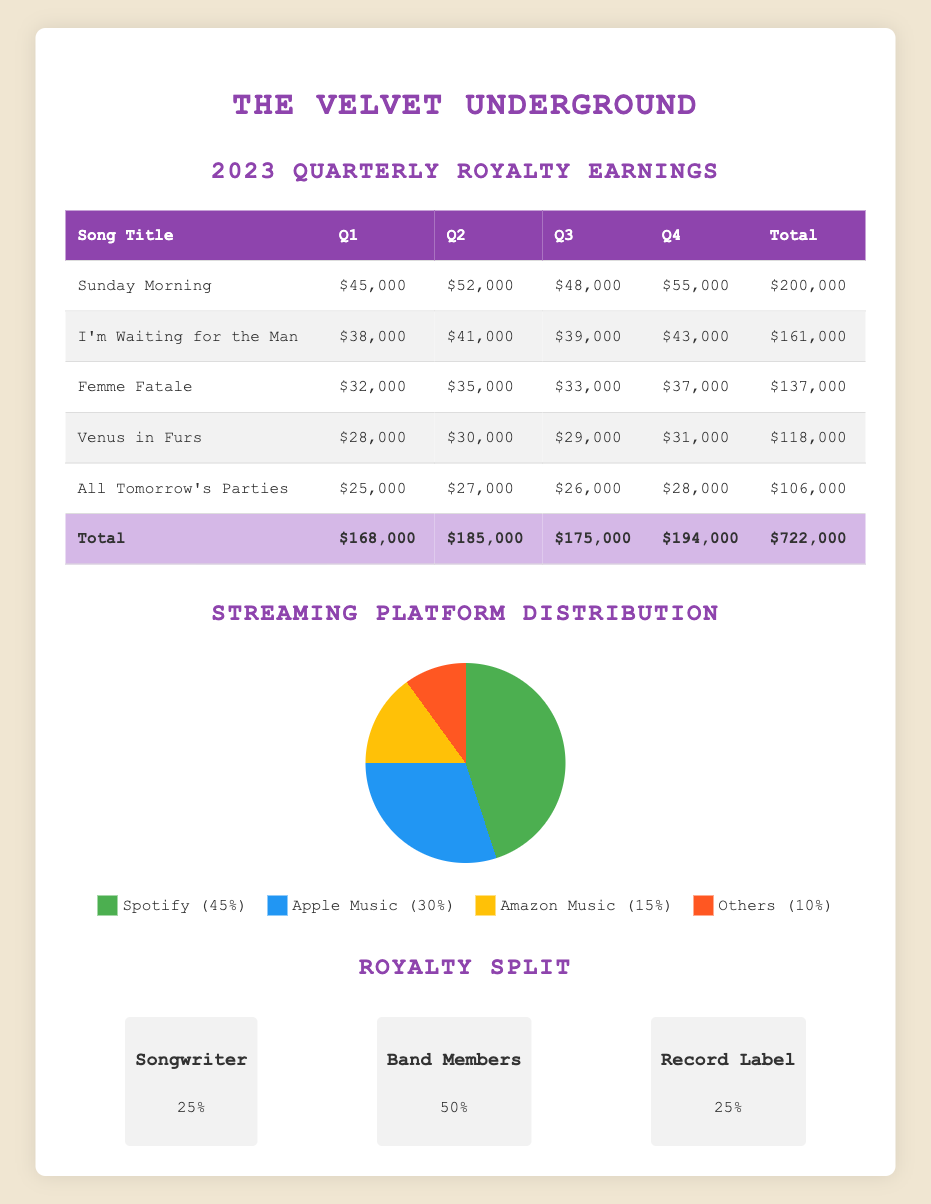What was the total royalty earnings for the song "Sunday Morning"? The total royalty for "Sunday Morning" is listed in the last column of the table under that song, which shows $200,000.
Answer: 200000 In which quarter did "Femme Fatale" earn its highest royalties? I need to look at the royalties for "Femme Fatale" across the quarters. In the Q4 column, "Femme Fatale" earned $37,000, which is the highest among its quarterly earnings listed.
Answer: Q4 What is the combined total of royalties earned by "All Tomorrow's Parties" and "Venus in Furs"? First, I look at the totals for both songs: "All Tomorrow's Parties" earned $106,000 and "Venus in Furs" earned $118,000. Adding these amounts gives $106,000 + $118,000 = $224,000.
Answer: 224000 How much more did "I'm Waiting for the Man" earn in Q2 compared to Q3? To find the difference, I compare the earnings for "I'm Waiting for the Man" in Q2 ($41,000) to Q3 ($39,000). The difference is $41,000 - $39,000 = $2,000.
Answer: 2000 Did any song earn less than $30,000 in the first quarter? By checking the Q1 earnings for all songs, "Venus in Furs" earned $28,000, which is less than $30,000, confirming that at least one song did earn less.
Answer: Yes Which song had the highest total earnings for the year 2023? To find this, I examine the total earnings for all songs in the last column. "Sunday Morning" has the highest total of $200,000 compared to others.
Answer: Sunday Morning What percentage of total royalties did the record label receive if the total earnings for the year are $722,000? The record label receives 25% of the total earnings. To find the amount, calculate 25% of $722,000, which is $180,500. Therefore, total received by the record label is 180500, confirming the percentage distribution in the split.
Answer: 180500 What is the average quarterly earning for the song "Venus in Furs"? The total royalty for "Venus in Furs" is $118,000, and this needs to be divided by the number of quarters (4). Thus, $118,000 / 4 equals $29,500 per quarter on average.
Answer: 29500 How does the total royal earnings for Q4 compare to Q1? I see the total for Q4 is $194,000 and for Q1 is $168,000. To find the difference, subtract Q1 from Q4: $194,000 - $168,000 = $26,000, indicating Q4 earned more.
Answer: 26000 